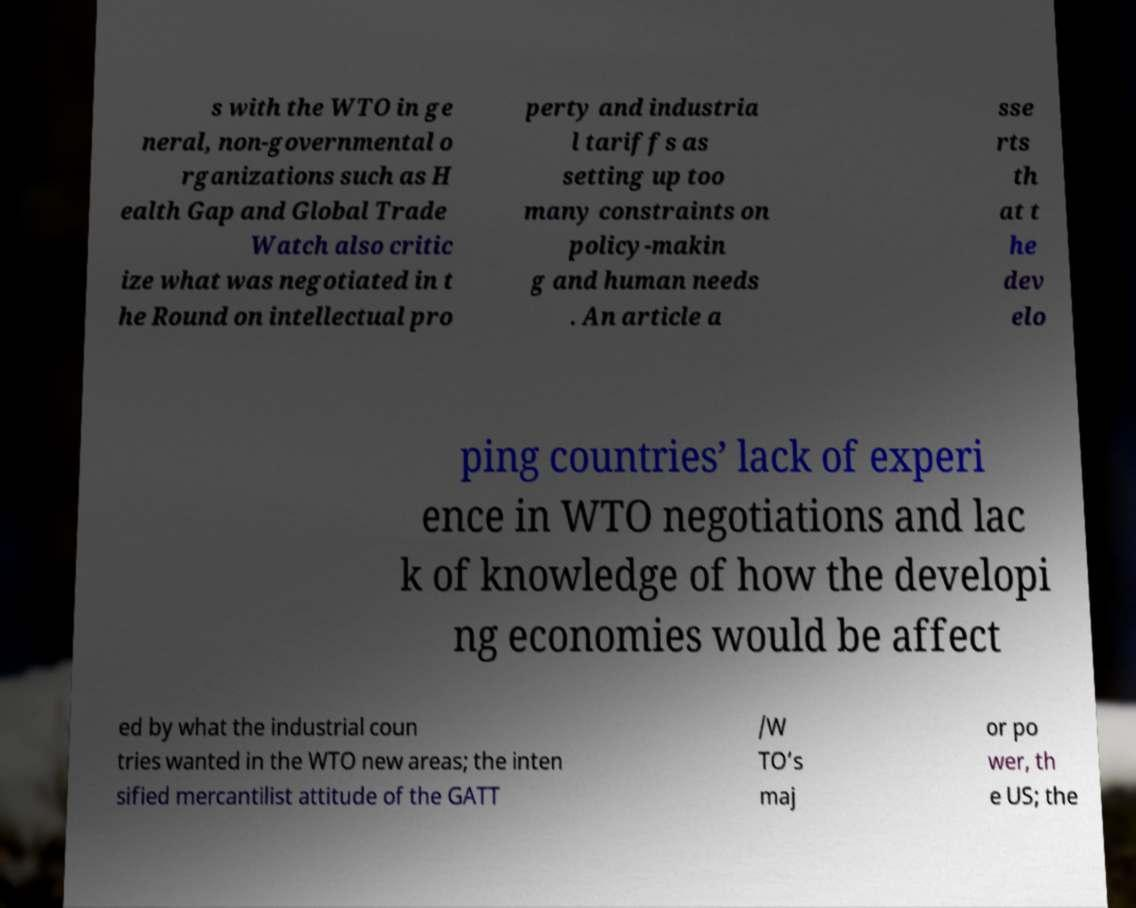I need the written content from this picture converted into text. Can you do that? s with the WTO in ge neral, non-governmental o rganizations such as H ealth Gap and Global Trade Watch also critic ize what was negotiated in t he Round on intellectual pro perty and industria l tariffs as setting up too many constraints on policy-makin g and human needs . An article a sse rts th at t he dev elo ping countries’ lack of experi ence in WTO negotiations and lac k of knowledge of how the developi ng economies would be affect ed by what the industrial coun tries wanted in the WTO new areas; the inten sified mercantilist attitude of the GATT /W TO’s maj or po wer, th e US; the 